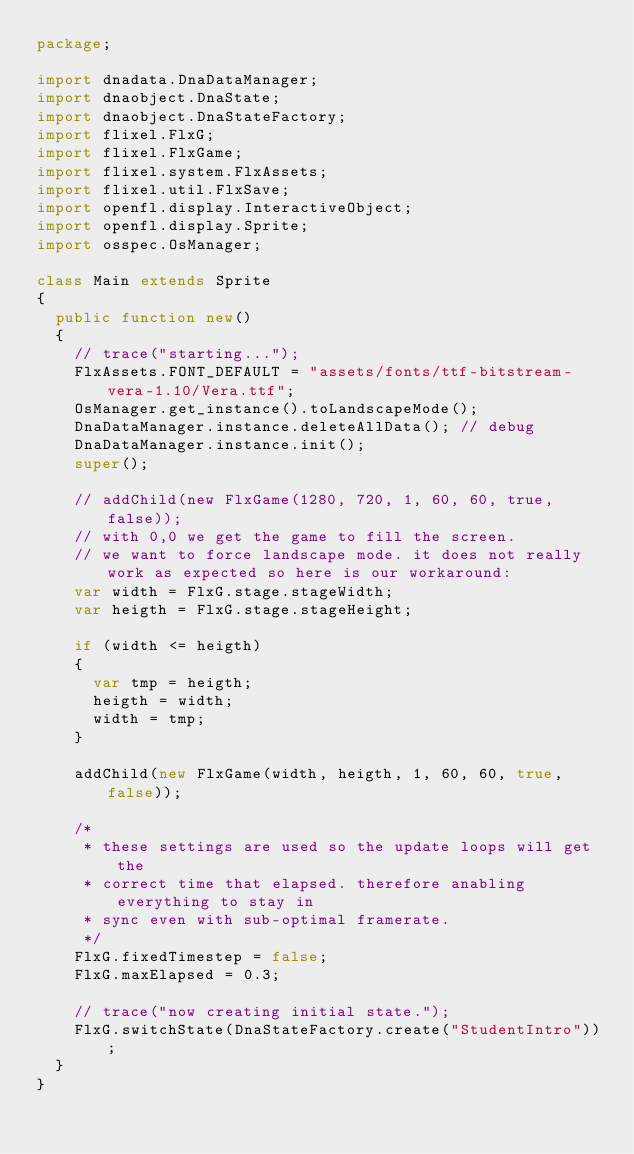<code> <loc_0><loc_0><loc_500><loc_500><_Haxe_>package;

import dnadata.DnaDataManager;
import dnaobject.DnaState;
import dnaobject.DnaStateFactory;
import flixel.FlxG;
import flixel.FlxGame;
import flixel.system.FlxAssets;
import flixel.util.FlxSave;
import openfl.display.InteractiveObject;
import openfl.display.Sprite;
import osspec.OsManager;

class Main extends Sprite
{
	public function new()
	{
		// trace("starting...");
		FlxAssets.FONT_DEFAULT = "assets/fonts/ttf-bitstream-vera-1.10/Vera.ttf";
		OsManager.get_instance().toLandscapeMode();
		DnaDataManager.instance.deleteAllData(); // debug
		DnaDataManager.instance.init();
		super();

		// addChild(new FlxGame(1280, 720, 1, 60, 60, true, false));
		// with 0,0 we get the game to fill the screen.
		// we want to force landscape mode. it does not really work as expected so here is our workaround:
		var width = FlxG.stage.stageWidth;
		var heigth = FlxG.stage.stageHeight;

		if (width <= heigth)
		{
			var tmp = heigth;
			heigth = width;
			width = tmp;
		}

		addChild(new FlxGame(width, heigth, 1, 60, 60, true, false));

		/*
		 * these settings are used so the update loops will get the 
		 * correct time that elapsed. therefore anabling everything to stay in
		 * sync even with sub-optimal framerate.
		 */
		FlxG.fixedTimestep = false;
		FlxG.maxElapsed = 0.3;

		// trace("now creating initial state.");
		FlxG.switchState(DnaStateFactory.create("StudentIntro"));
	}
}
</code> 